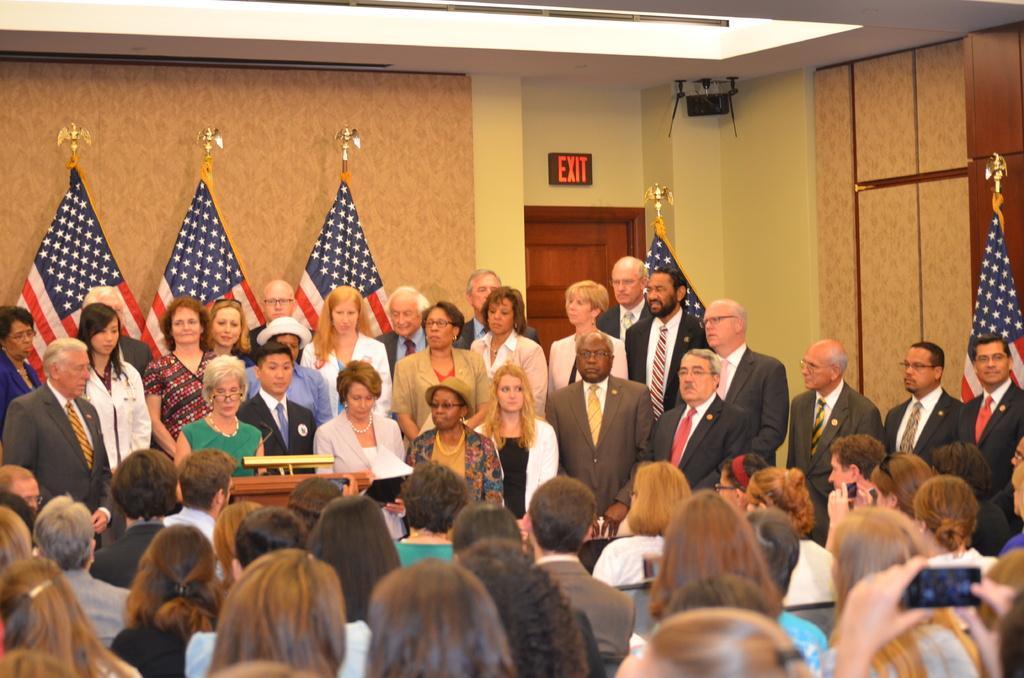Describe this image in one or two sentences. At the bottom of the image there are many people sitting on the chairs. In front of them there is a podium. Behind the podium there is a lady and also there are many people standing. Behind them there are poles with flags. And in the background there are walls and also there is a door and an exit board. At the top of the image there is ceiling with lights and also there is a black color object in the corner on the wall. 